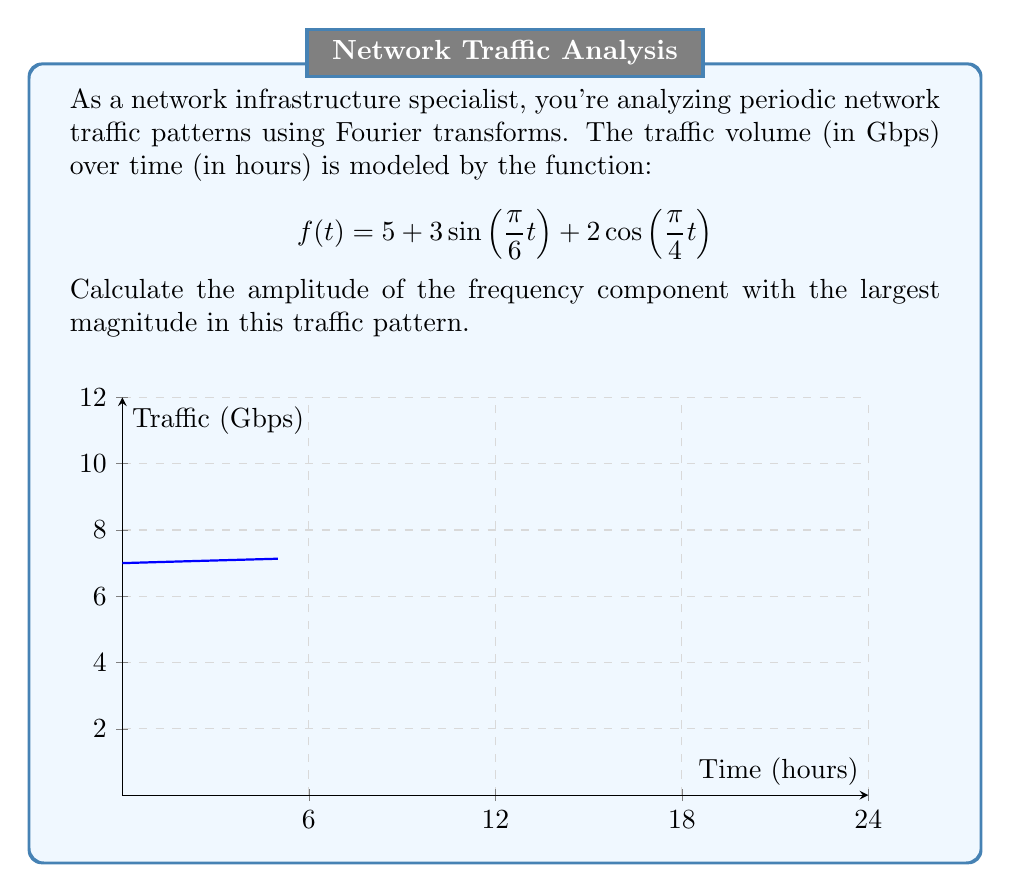Provide a solution to this math problem. To find the amplitude of the frequency component with the largest magnitude, we need to analyze the sinusoidal terms in the given function:

1) The function is composed of a constant term and two sinusoidal terms:
   $$f(t) = 5 + 3\sin(\frac{\pi}{6}t) + 2\cos(\frac{\pi}{4}t)$$

2) The amplitudes of the sinusoidal terms are:
   - For $3\sin(\frac{\pi}{6}t)$: A₁ = 3
   - For $2\cos(\frac{\pi}{4}t)$: A₂ = 2

3) The constant term (5) represents the DC component and doesn't contribute to the periodic behavior.

4) Compare the amplitudes:
   A₁ = 3 > A₂ = 2

5) Therefore, the sinusoidal term with the largest magnitude is $3\sin(\frac{\pi}{6}t)$.

The amplitude of this term is 3 Gbps.
Answer: 3 Gbps 